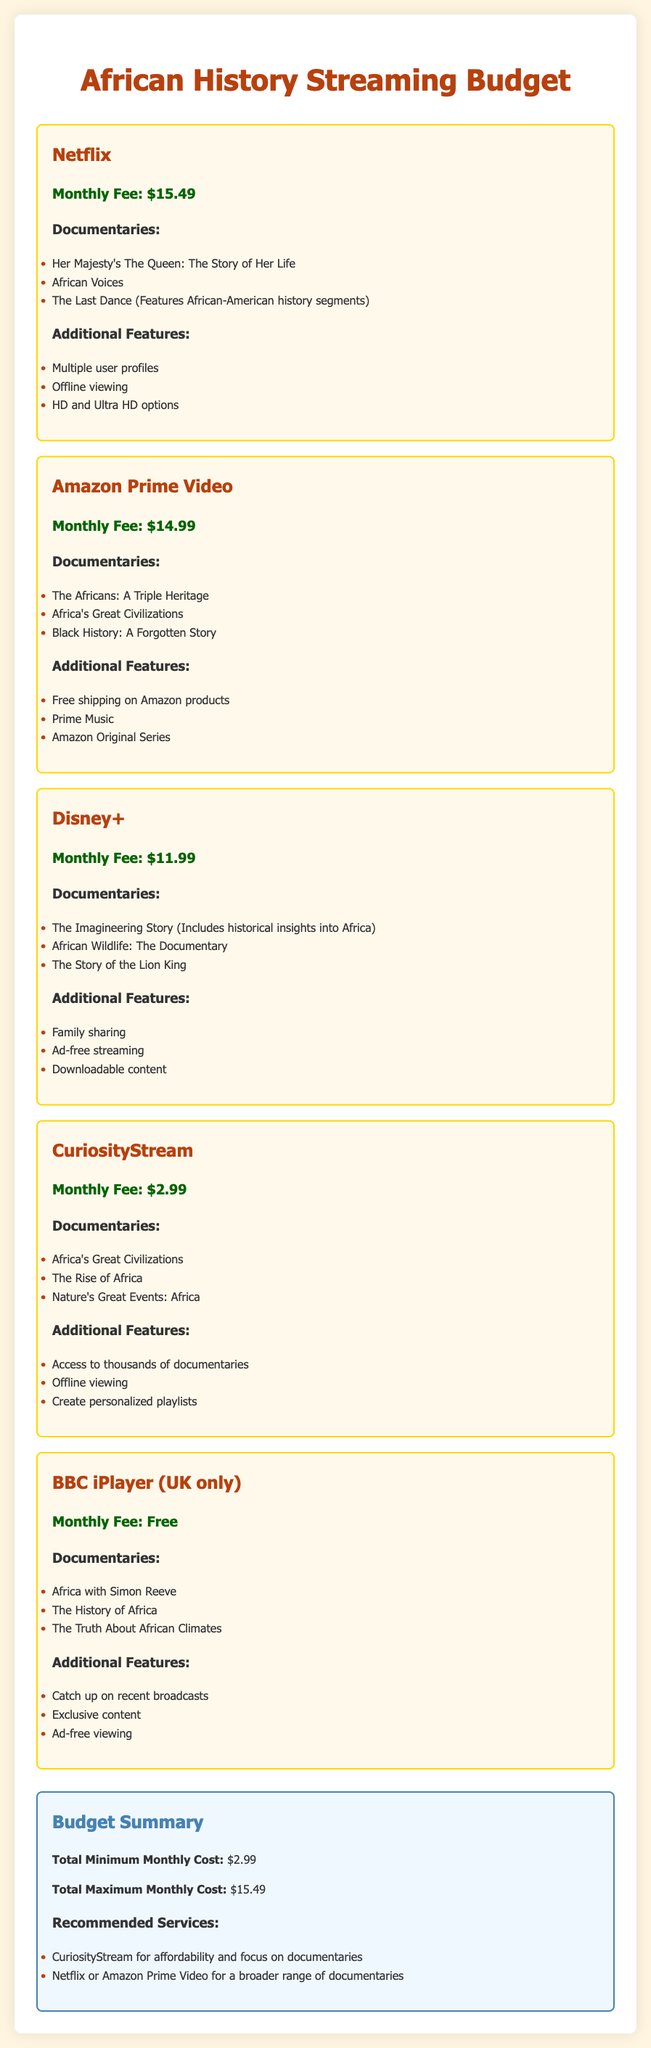What is the monthly fee for Netflix? The monthly fee for Netflix is listed under the service section, which states it is $15.49.
Answer: $15.49 How many documentaries does Amazon Prime Video have listed? The number of documentaries is found in the subsections under Amazon Prime Video, which lists three titles.
Answer: 3 What additional feature is offered by CuriosityStream? One of the listed additional features for CuriosityStream is creating personalized playlists, as mentioned in the features section.
Answer: Create personalized playlists What is the total minimum monthly cost? The total minimum monthly cost is found in the budget summary at the end of the document, which states it is $2.99.
Answer: $2.99 Which service is available for free? The service that is free can be identified in the service section, where BBC iPlayer states its monthly fee as free.
Answer: Free How many streaming services are listed in the document? The count of streaming services can be calculated by totaling the individual service sections, which shows five in total.
Answer: 5 What specific documentary does Disney+ feature about African wildlife? This information can be found in the Disney+ section, where "African Wildlife: The Documentary" is specifically listed.
Answer: African Wildlife: The Documentary What is a recommended service for a broader range of documentaries? The summary section provides recommendations, and it suggests Netflix or Amazon Prime Video for a broader range.
Answer: Netflix or Amazon Prime Video 